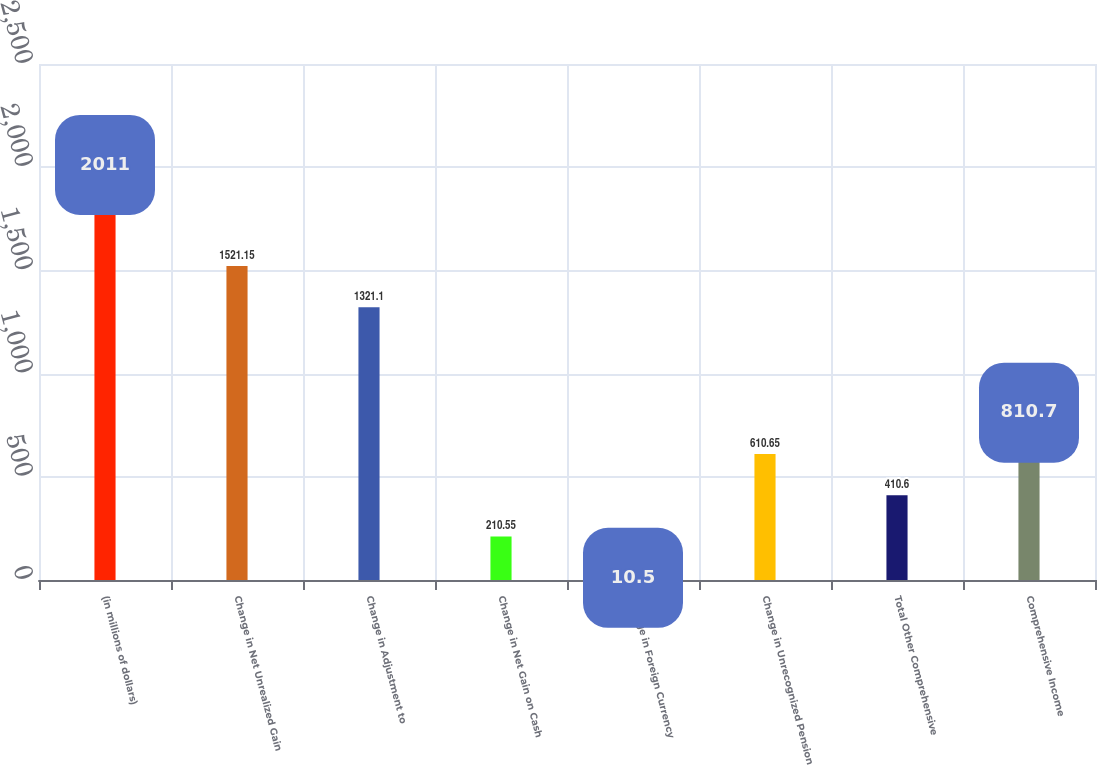<chart> <loc_0><loc_0><loc_500><loc_500><bar_chart><fcel>(in millions of dollars)<fcel>Change in Net Unrealized Gain<fcel>Change in Adjustment to<fcel>Change in Net Gain on Cash<fcel>Change in Foreign Currency<fcel>Change in Unrecognized Pension<fcel>Total Other Comprehensive<fcel>Comprehensive Income<nl><fcel>2011<fcel>1521.15<fcel>1321.1<fcel>210.55<fcel>10.5<fcel>610.65<fcel>410.6<fcel>810.7<nl></chart> 